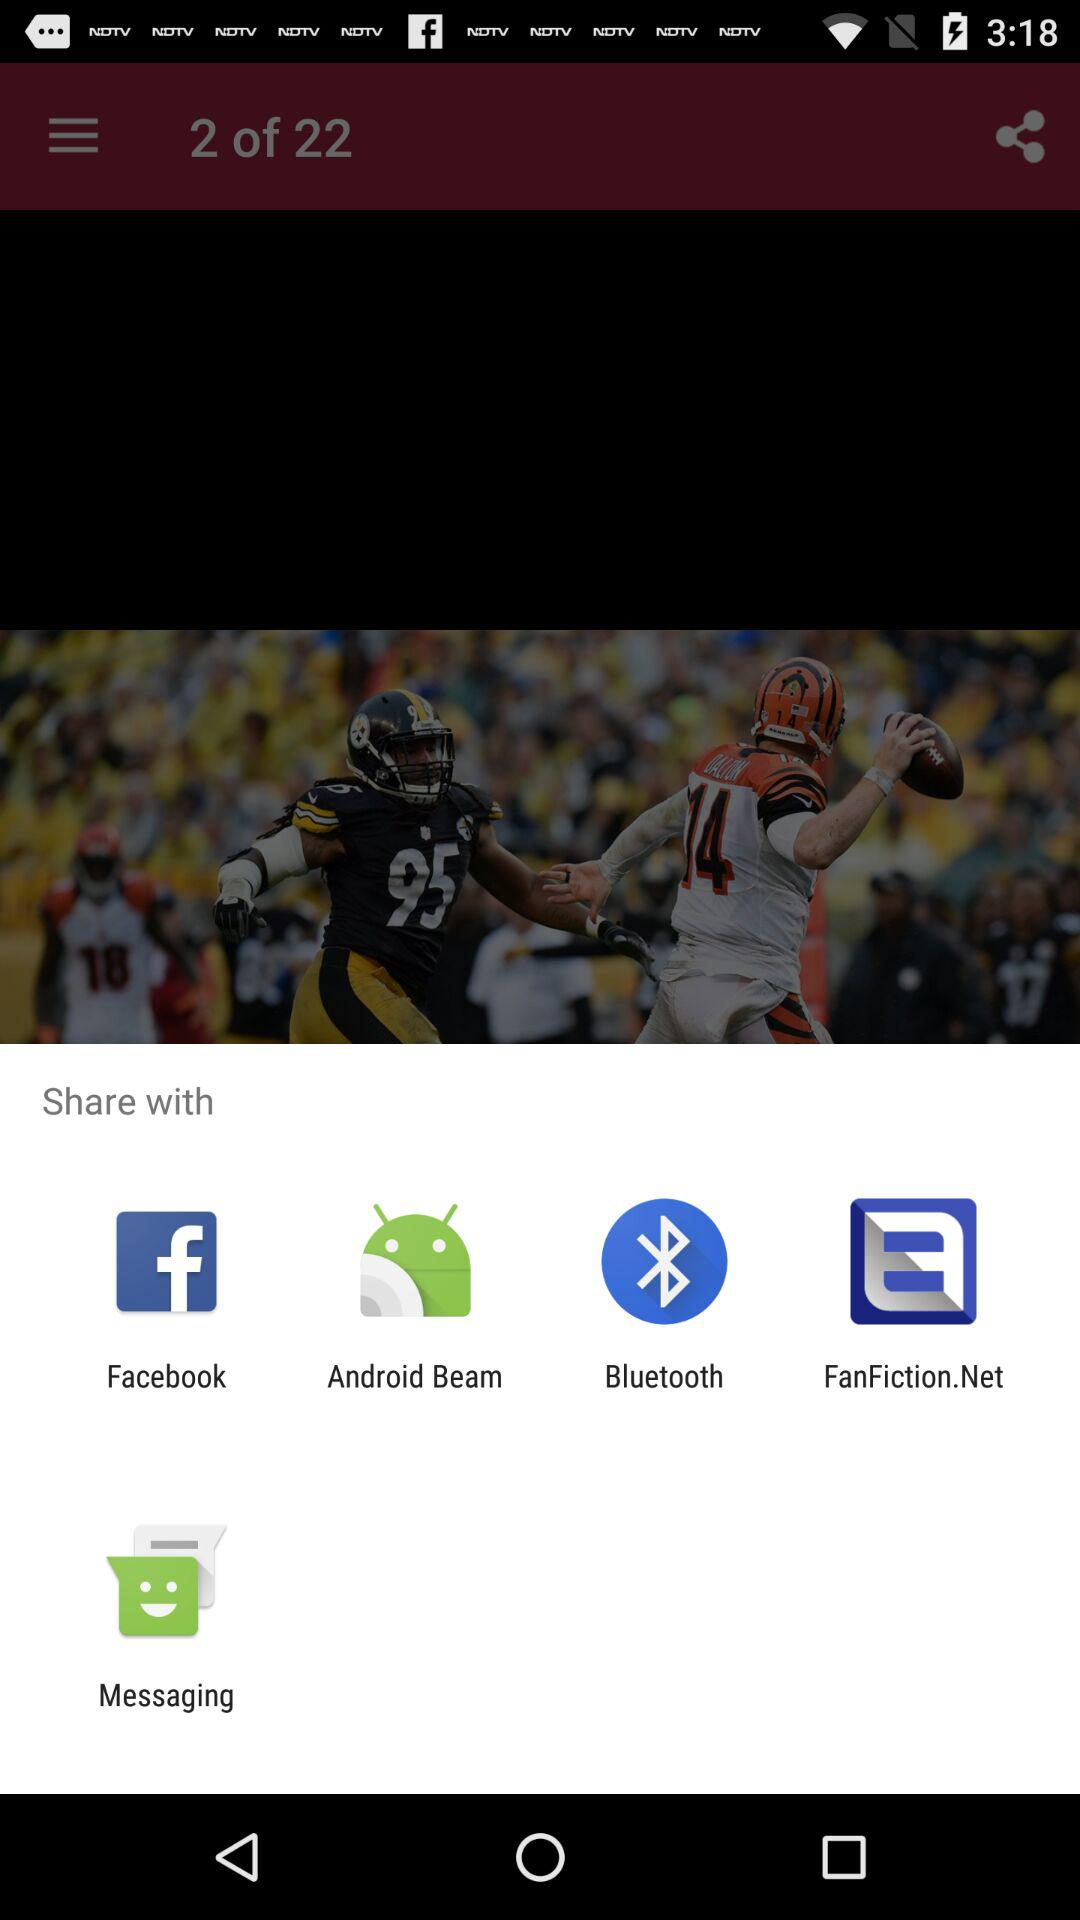How many items are in the share menu? There are five items in the share menu. These include icons for Facebook, Android Beam, Bluetooth, Fanfiction.Net, and Messaging, enabling users to share content through various platforms and applications. 